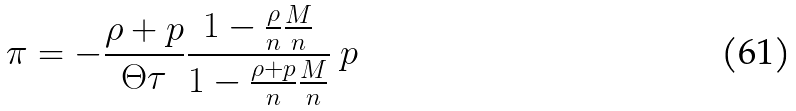<formula> <loc_0><loc_0><loc_500><loc_500>\pi = - \frac { \rho + p } { \Theta \tau } \frac { 1 - \frac { \rho } { n } \frac { M } { n } } { 1 - \frac { \rho + p } { n } \frac { M } { n } } \ p</formula> 